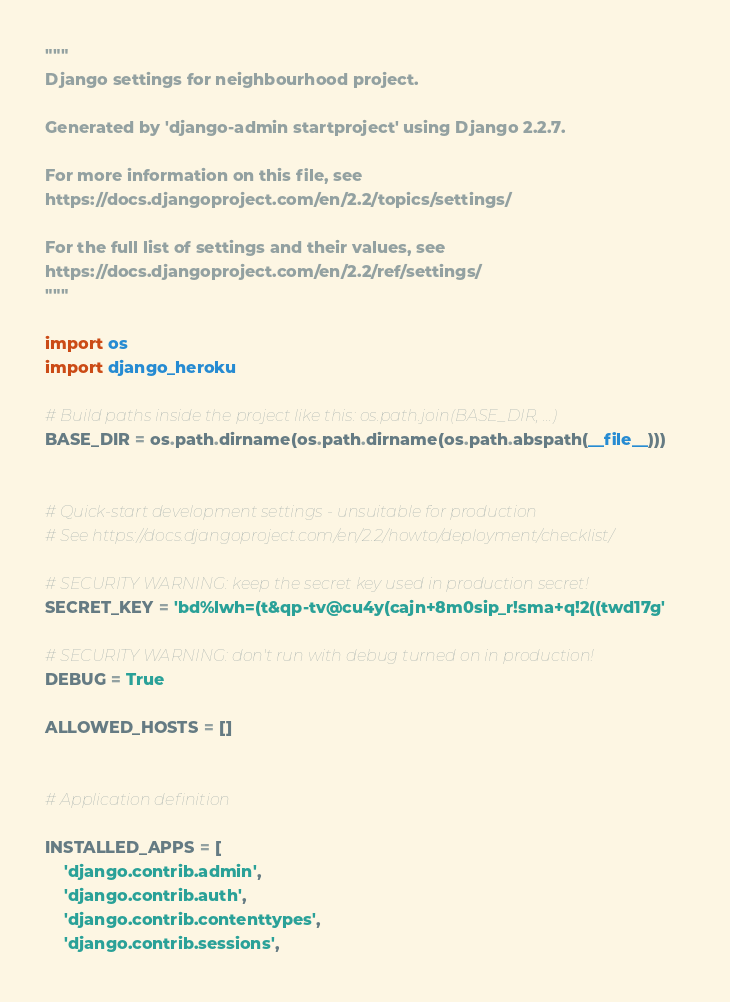Convert code to text. <code><loc_0><loc_0><loc_500><loc_500><_Python_>"""
Django settings for neighbourhood project.

Generated by 'django-admin startproject' using Django 2.2.7.

For more information on this file, see
https://docs.djangoproject.com/en/2.2/topics/settings/

For the full list of settings and their values, see
https://docs.djangoproject.com/en/2.2/ref/settings/
"""

import os
import django_heroku 

# Build paths inside the project like this: os.path.join(BASE_DIR, ...)
BASE_DIR = os.path.dirname(os.path.dirname(os.path.abspath(__file__)))


# Quick-start development settings - unsuitable for production
# See https://docs.djangoproject.com/en/2.2/howto/deployment/checklist/

# SECURITY WARNING: keep the secret key used in production secret!
SECRET_KEY = 'bd%lwh=(t&qp-tv@cu4y(cajn+8m0sip_r!sma+q!2((twd17g'

# SECURITY WARNING: don't run with debug turned on in production!
DEBUG = True

ALLOWED_HOSTS = []


# Application definition

INSTALLED_APPS = [
    'django.contrib.admin',
    'django.contrib.auth',
    'django.contrib.contenttypes',
    'django.contrib.sessions',</code> 